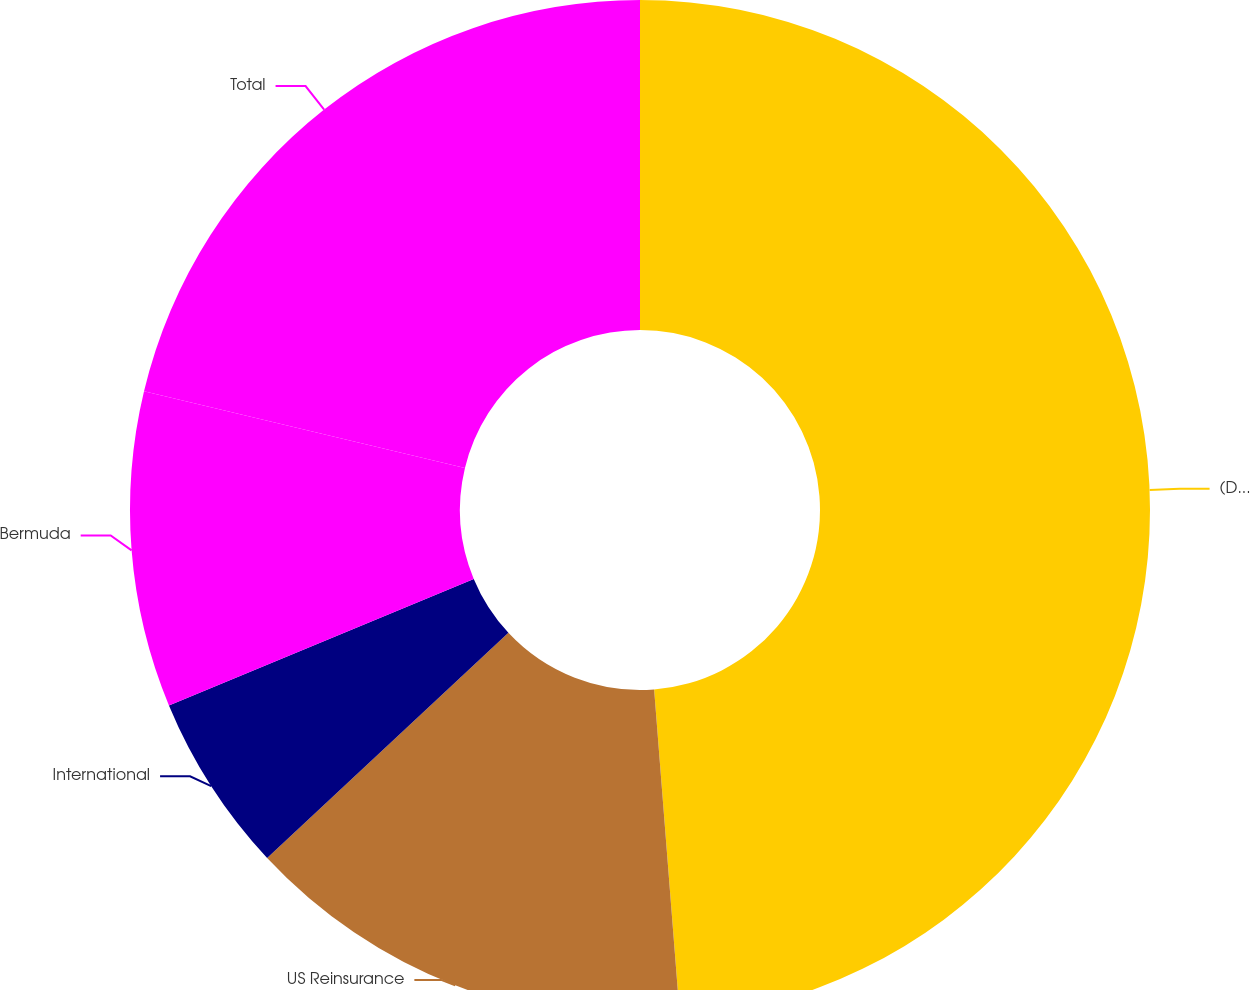Convert chart to OTSL. <chart><loc_0><loc_0><loc_500><loc_500><pie_chart><fcel>(Dollars in millions)<fcel>US Reinsurance<fcel>International<fcel>Bermuda<fcel>Total<nl><fcel>48.75%<fcel>14.3%<fcel>5.69%<fcel>10.0%<fcel>21.26%<nl></chart> 